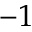Convert formula to latex. <formula><loc_0><loc_0><loc_500><loc_500>- 1</formula> 